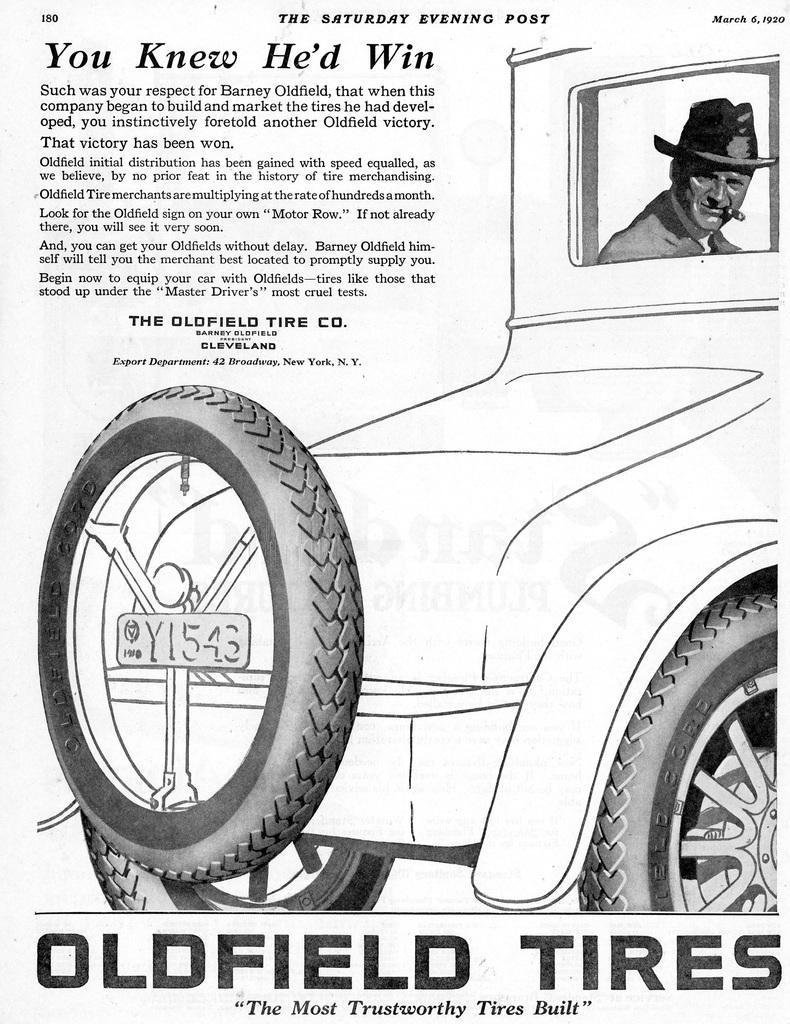Describe this image in one or two sentences. In this image I can see a person, vehicle and a text. This image looks like a newspaper cutting. 